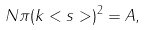<formula> <loc_0><loc_0><loc_500><loc_500>N \pi ( k < s > ) ^ { 2 } = A ,</formula> 